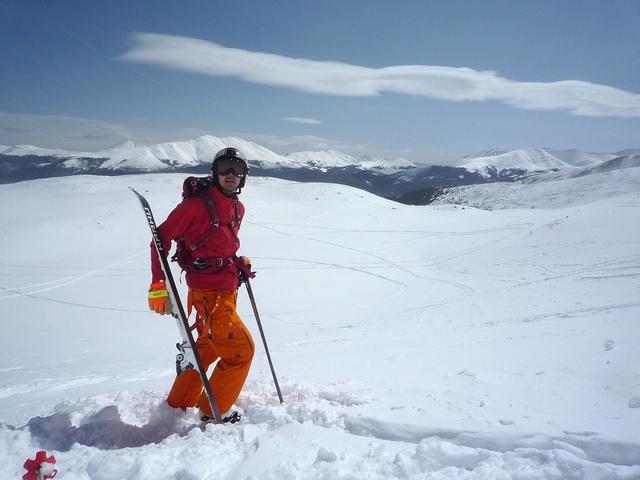Can this person be seen from far away?
Concise answer only. Yes. Where is the man standing on?
Be succinct. Snow. What is the person doing?
Quick response, please. Skiing. 